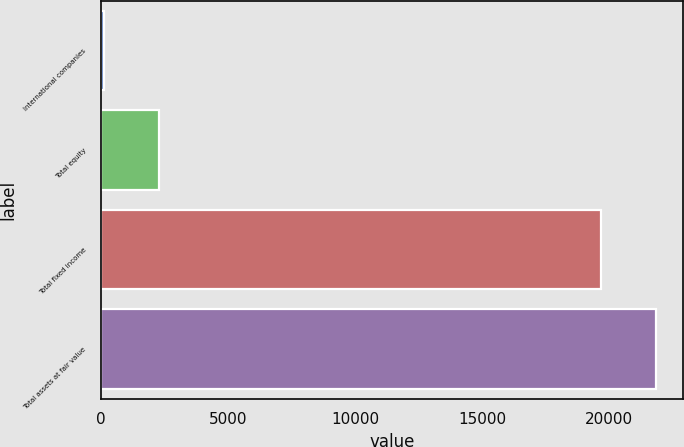Convert chart. <chart><loc_0><loc_0><loc_500><loc_500><bar_chart><fcel>International companies<fcel>Total equity<fcel>Total fixed income<fcel>Total assets at fair value<nl><fcel>133<fcel>2290.7<fcel>19670<fcel>21827.7<nl></chart> 